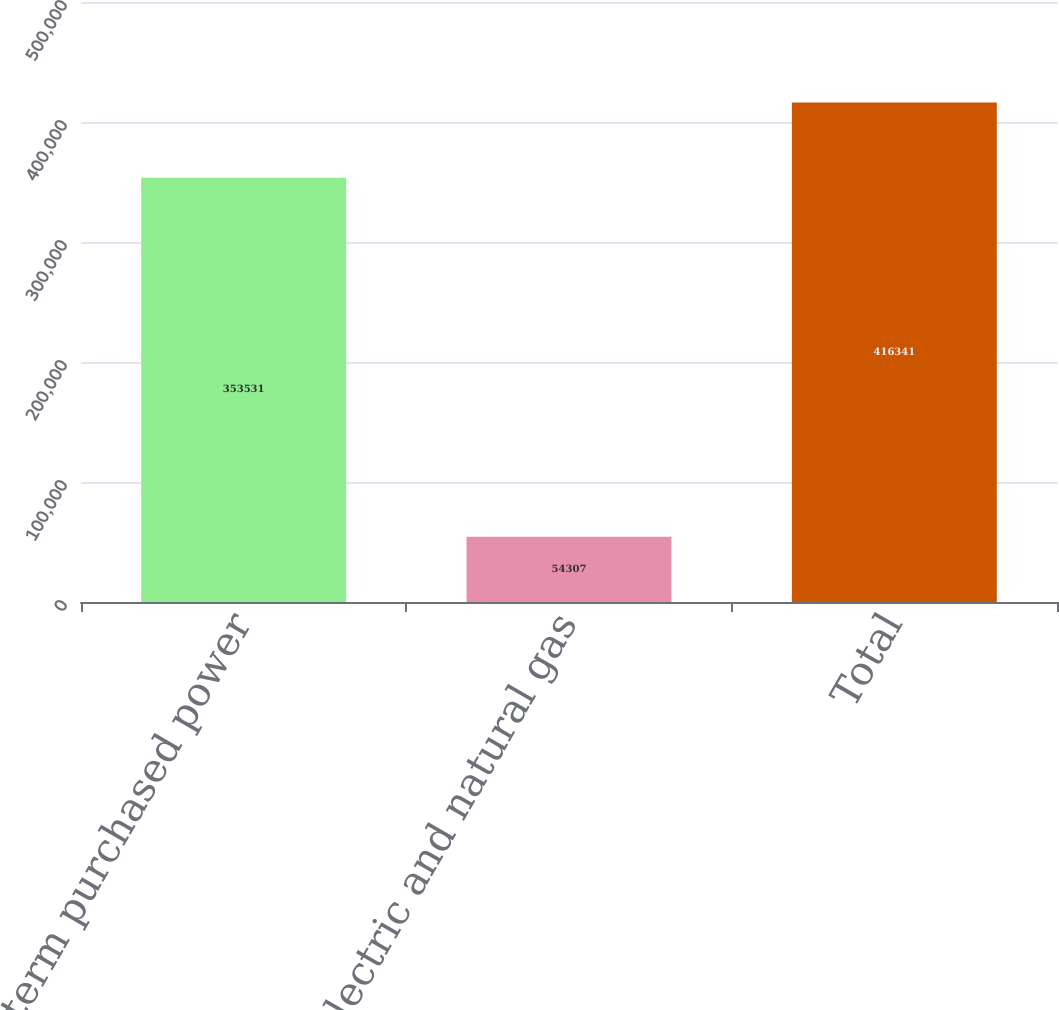Convert chart to OTSL. <chart><loc_0><loc_0><loc_500><loc_500><bar_chart><fcel>Long-term purchased power<fcel>Electric and natural gas<fcel>Total<nl><fcel>353531<fcel>54307<fcel>416341<nl></chart> 